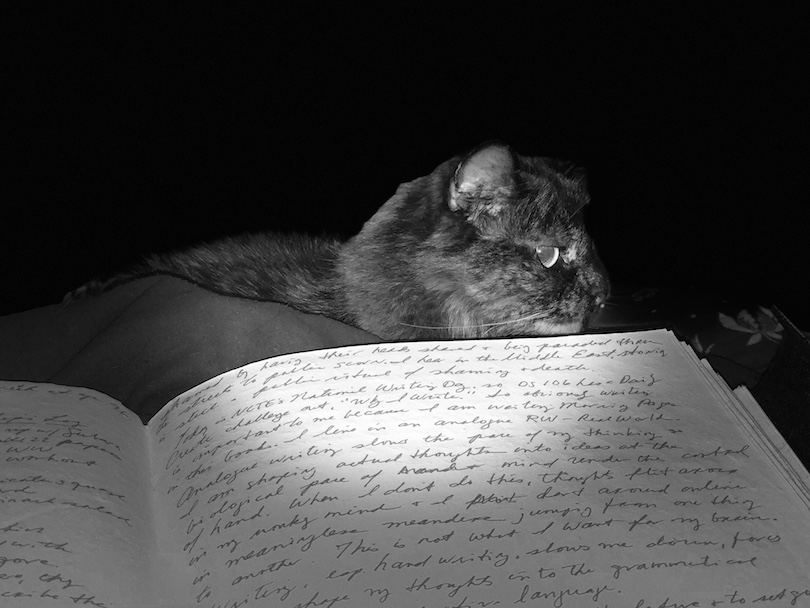What artistic techniques might the photographer have employed to enhance the dramatic contrast seen in this image? To achieve the stark dramatic contrast evident in the image, the photographer likely used high-contrast black and white film or a digital black and white setting that mimics this effect. Techniques such as dodging and burning could have been employed during post-processing to further enhance the light and shadow interplay, deepening the darks and highlighting the lights to create a more vivid and texturally rich image. This technique not only highlights the main subject but also adds a layer of emotional depth and intensity to the picture. 